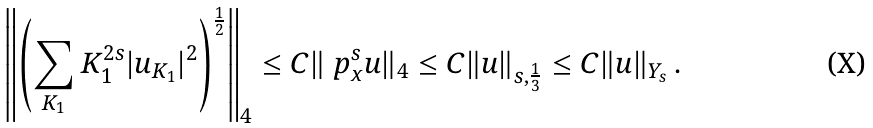Convert formula to latex. <formula><loc_0><loc_0><loc_500><loc_500>\left \| \left ( \sum _ { K _ { 1 } } K _ { 1 } ^ { 2 s } | u _ { K _ { 1 } } | ^ { 2 } \right ) ^ { \frac { 1 } { 2 } } \right \| _ { 4 } \leq C \| \ p _ { x } ^ { s } u \| _ { 4 } \leq C \| u \| _ { s , \frac { 1 } { 3 } } \leq C \| u \| _ { Y _ { s } } \, .</formula> 